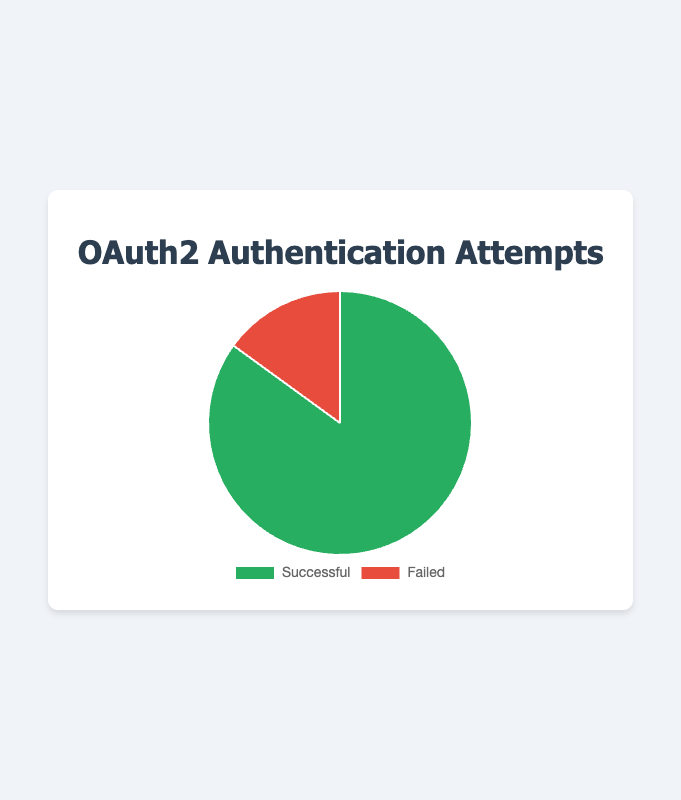What's the percentage of failed authentication attempts? The pie chart shows the count of successful and failed attempts. There are 850 successful and 150 failed attempts. The total number of attempts is 850 + 150 = 1000. The percentage of failed attempts is (150 / 1000) * 100 = 15%
Answer: 15% Which category has a larger count, successful or failed attempts? By comparing the two categories, successful attempts have a count of 850, and failed attempts have a count of 150. Since 850 is larger than 150, successful attempts have a larger count
Answer: Successful What is the ratio of successful to failed authentication attempts? The count of successful attempts is 850 and failed attempts is 150. The ratio is calculated as 850 / 150 = 5.67
Answer: 5.67 If the number of failed attempts doubled, what would be the new percentage of successful attempts? If failed attempts doubled, they would be 150 * 2 = 300. Total attempts would then be 850 + 300 = 1150. The new percentage of successful attempts would be (850 / 1150) * 100 ≈ 73.91%
Answer: 73.91% What fraction of the total authentication attempts were successful? The total number of attempts is 850 successful + 150 failed = 1000. The fraction of successful attempts is 850 / 1000 = 0.85
Answer: 0.85 By how much do successful attempts exceed failed attempts? There are 850 successful attempts and 150 failed attempts. The difference is 850 - 150 = 700
Answer: 700 What is the combined count of successful and failed authentication attempts? The counts are 850 successful and 150 failed. Summing these gives 850 + 150 = 1000
Answer: 1000 How many degrees does the successful attempts segment occupy in the pie chart? Successful attempts make up 85% of the total attempts (850 / 1000 * 100). In a pie chart, 100% corresponds to 360 degrees, so 85% corresponds to 0.85 * 360 = 306 degrees
Answer: 306 What is the percentage difference between successful and failed attempts? Successful attempts are 850, and failed attempts are 150. The percentage difference is ((850 - 150) / 1000) * 100 = 70%
Answer: 70% If 100 more failed attempts were logged, what would be the new ratio of successful to failed attempts? Adding 100 to the failed attempts means 150 + 100 = 250. The new ratio of successful (850) to failed (250) attempts is 850 / 250 = 3.4
Answer: 3.4 